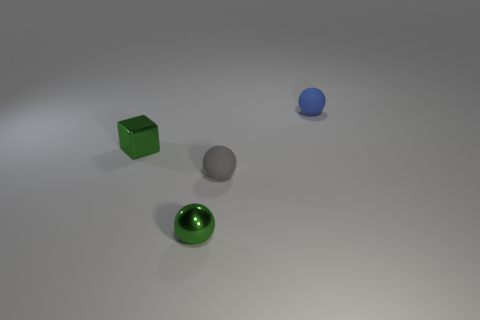How many small gray rubber things have the same shape as the small blue thing?
Offer a very short reply. 1. How big is the matte thing in front of the blue matte thing that is to the right of the matte ball that is left of the blue thing?
Give a very brief answer. Small. Are there more tiny balls that are in front of the blue matte thing than gray things?
Ensure brevity in your answer.  Yes. Are any tiny yellow matte cylinders visible?
Give a very brief answer. No. How many blue things have the same size as the green metallic cube?
Keep it short and to the point. 1. Is the number of green shiny balls in front of the tiny gray sphere greater than the number of tiny matte objects that are in front of the shiny cube?
Provide a succinct answer. No. There is a gray thing that is the same size as the metallic sphere; what is it made of?
Your response must be concise. Rubber. What is the shape of the gray rubber thing?
Your answer should be compact. Sphere. What number of blue objects are either tiny matte things or blocks?
Make the answer very short. 1. Do the thing that is behind the metallic block and the green thing that is in front of the gray matte object have the same material?
Offer a terse response. No. 